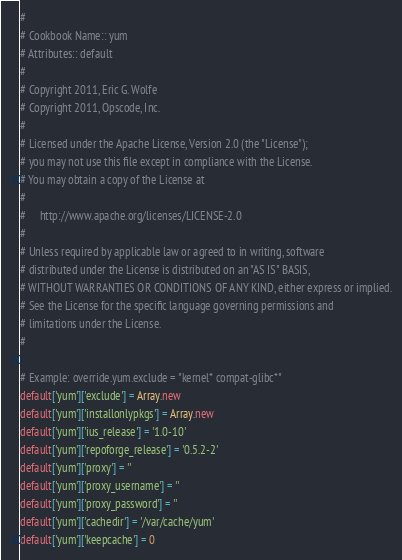Convert code to text. <code><loc_0><loc_0><loc_500><loc_500><_Ruby_>#
# Cookbook Name:: yum
# Attributes:: default
#
# Copyright 2011, Eric G. Wolfe
# Copyright 2011, Opscode, Inc.
#
# Licensed under the Apache License, Version 2.0 (the "License");
# you may not use this file except in compliance with the License.
# You may obtain a copy of the License at
#
#     http://www.apache.org/licenses/LICENSE-2.0
#
# Unless required by applicable law or agreed to in writing, software
# distributed under the License is distributed on an "AS IS" BASIS,
# WITHOUT WARRANTIES OR CONDITIONS OF ANY KIND, either express or implied.
# See the License for the specific language governing permissions and
# limitations under the License.
#

# Example: override.yum.exclude = "kernel* compat-glibc*"
default['yum']['exclude'] = Array.new
default['yum']['installonlypkgs'] = Array.new
default['yum']['ius_release'] = '1.0-10'
default['yum']['repoforge_release'] = '0.5.2-2'
default['yum']['proxy'] = ''
default['yum']['proxy_username'] = ''
default['yum']['proxy_password'] = ''
default['yum']['cachedir'] = '/var/cache/yum'
default['yum']['keepcache'] = 0
</code> 